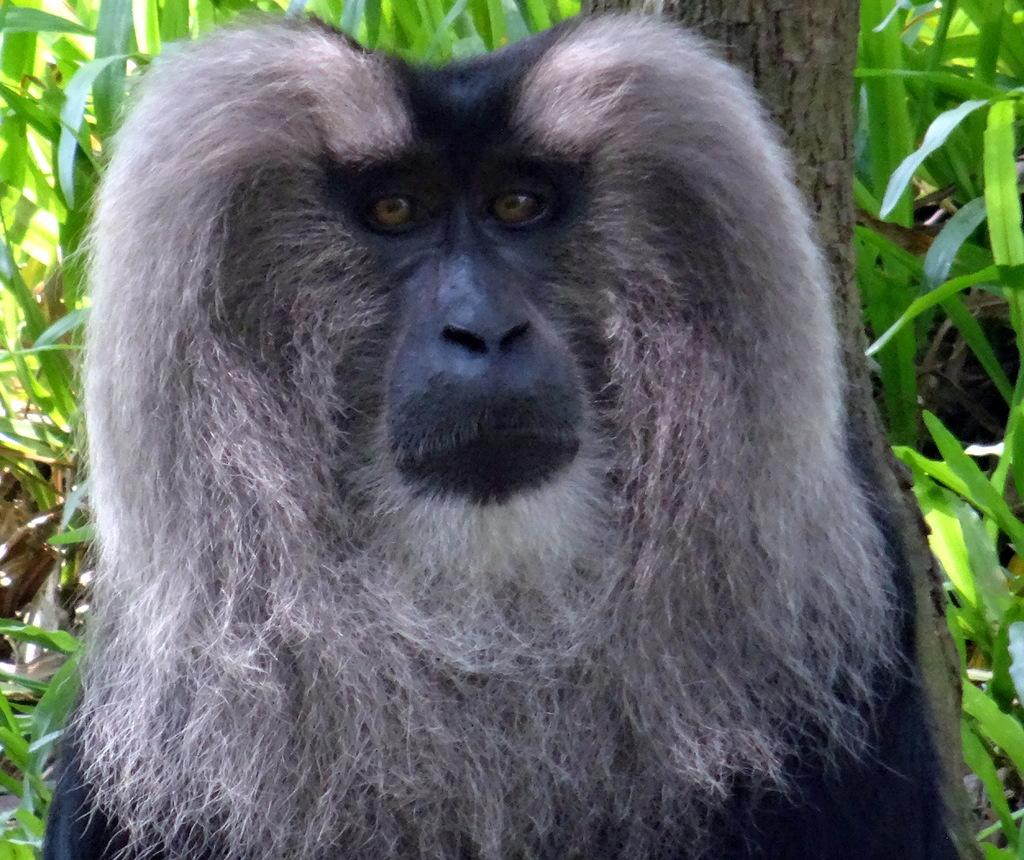What animal is the main subject of the image? There is a gorilla in the image. What is located behind the gorilla? There is a tree trunk behind the gorilla. What type of vegetation can be seen in the image? There are plants in the image. What type of memory does the gorilla have in the image? There is no indication of the gorilla's memory in the image, as it is a photograph and cannot show the animal's thoughts or emotions. 